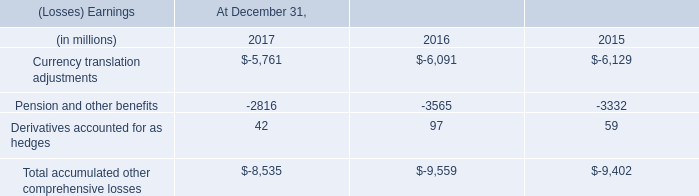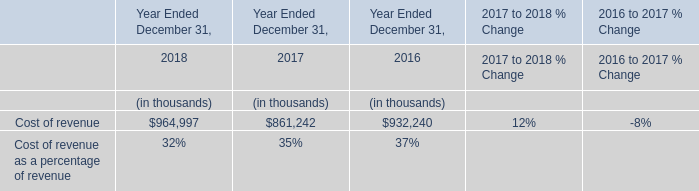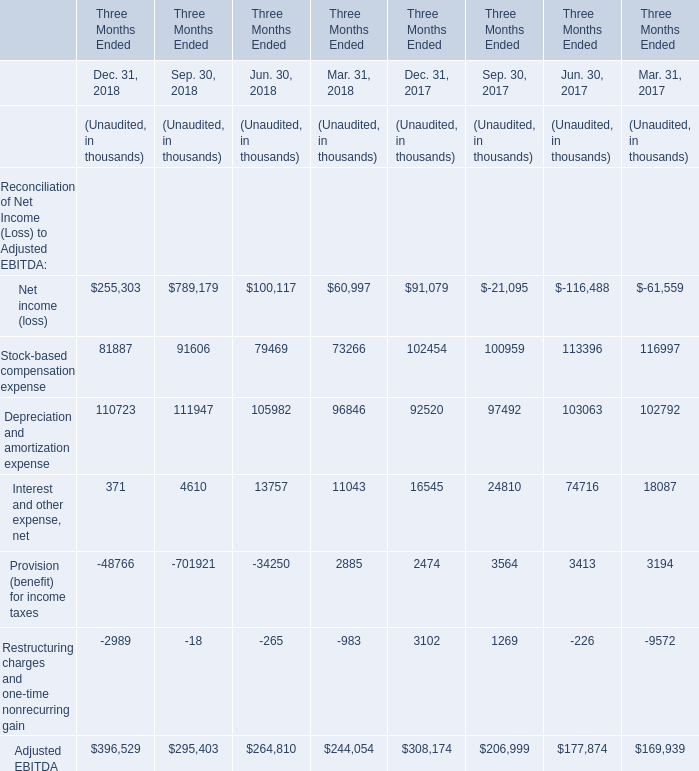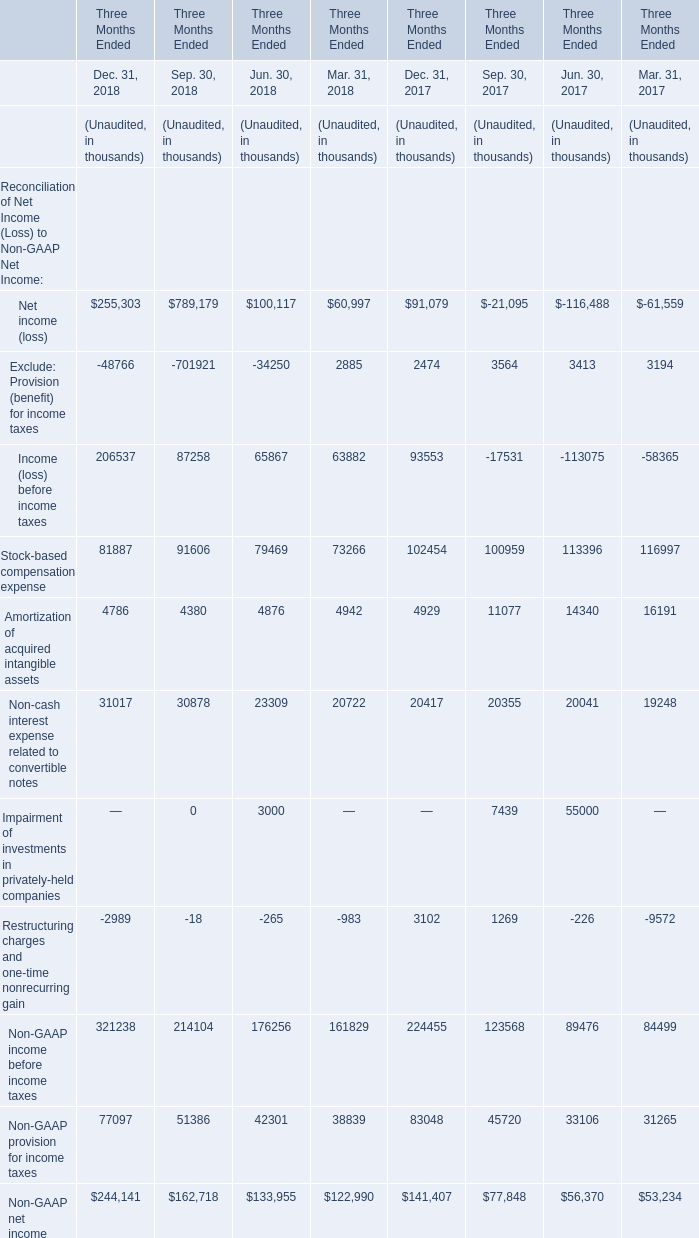How many kinds of Reconciliation of Net Income (Loss) to Non-GAAP Net Income are greater than 300000 in Dec.31,2018? 
Answer: 1(Non-GAAP income before income taxes). 